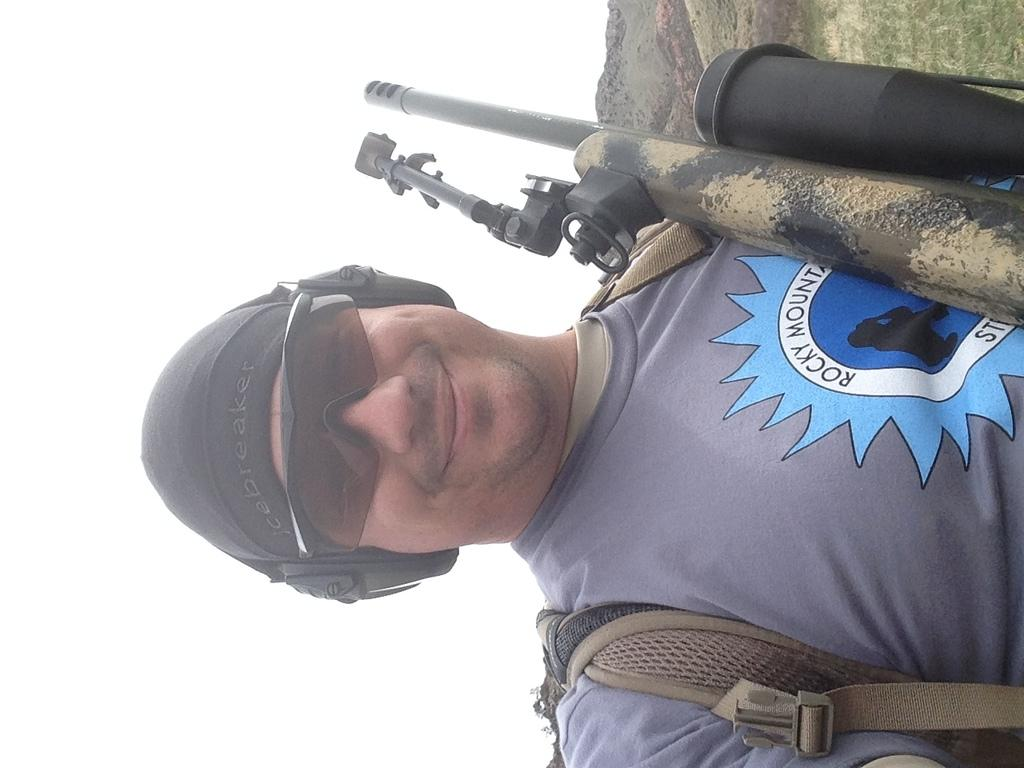What can be seen in the image? There is a person in the image. Can you describe the person's attire? The person is wearing clothes, sunglasses, a headset, and a cap. What is the person holding in the image? The person has a bag. Is there anything else visible in the image? There is a gun in the top right of the image, and a sky is visible on the left side of the image. How many toes can be seen on the person's feet in the image? There is no visible feet or toes in the image, as the person is wearing a cap and the focus is on their upper body. 